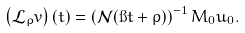Convert formula to latex. <formula><loc_0><loc_0><loc_500><loc_500>\left ( \mathcal { L } _ { \rho } v \right ) ( t ) = \left ( \mathcal { N } ( \i t + \rho ) \right ) ^ { - 1 } M _ { 0 } u _ { 0 } .</formula> 